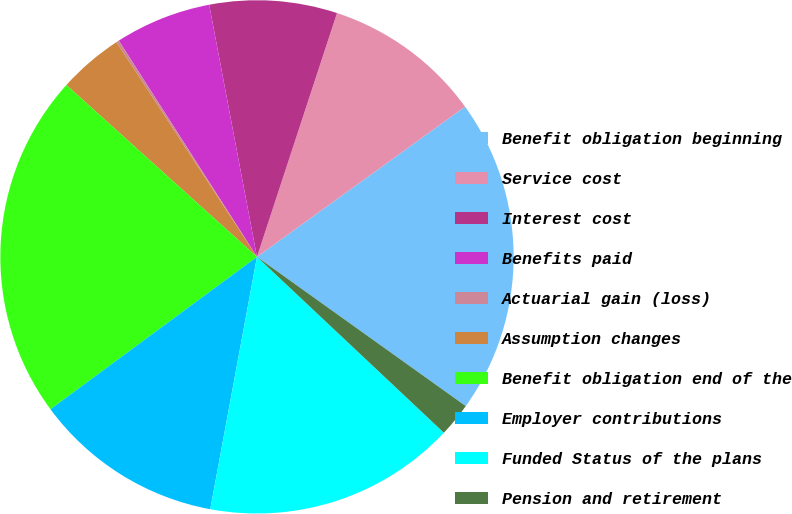<chart> <loc_0><loc_0><loc_500><loc_500><pie_chart><fcel>Benefit obligation beginning<fcel>Service cost<fcel>Interest cost<fcel>Benefits paid<fcel>Actuarial gain (loss)<fcel>Assumption changes<fcel>Benefit obligation end of the<fcel>Employer contributions<fcel>Funded Status of the plans<fcel>Pension and retirement<nl><fcel>19.83%<fcel>10.0%<fcel>8.03%<fcel>6.07%<fcel>0.17%<fcel>4.1%<fcel>21.8%<fcel>11.97%<fcel>15.9%<fcel>2.14%<nl></chart> 